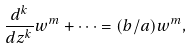<formula> <loc_0><loc_0><loc_500><loc_500>\frac { d ^ { k } } { d z ^ { k } } w ^ { m } + \cdots = ( b / a ) w ^ { m } ,</formula> 